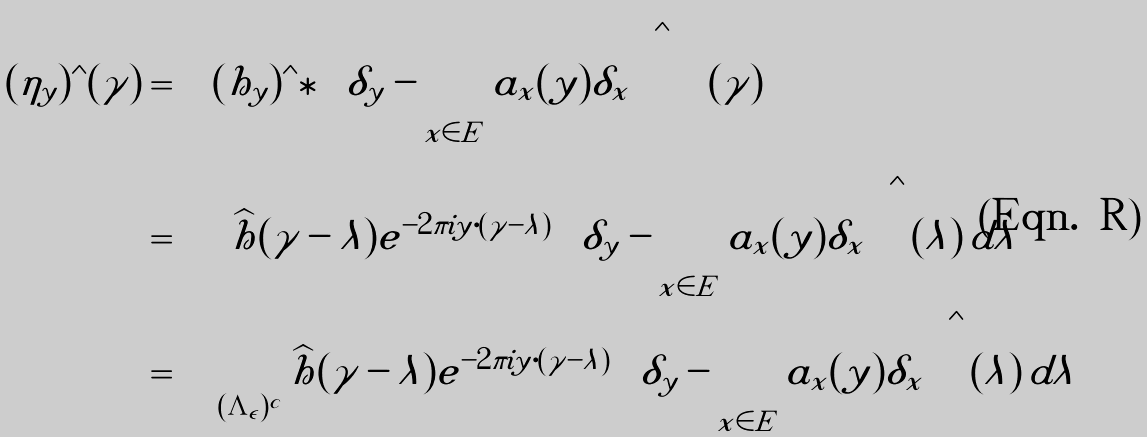Convert formula to latex. <formula><loc_0><loc_0><loc_500><loc_500>( \eta _ { y } ) ^ { \wedge } ( \gamma ) & = \left [ ( h _ { y } ) ^ { \wedge } \ast \left ( \delta _ { y } - \sum _ { x \in E } a _ { x } ( y ) \delta _ { x } \right ) ^ { \wedge } \right ] ( \gamma ) \\ & = \int \widehat { h } ( \gamma - \lambda ) e ^ { - 2 \pi i y \cdot ( \gamma - \lambda ) } \left ( \delta _ { y } - \sum _ { x \in E } a _ { x } ( y ) \delta _ { x } \right ) ^ { \wedge } ( \lambda ) \, d \lambda \\ & = \int _ { ( \Lambda _ { \epsilon } ) ^ { c } } \widehat { h } ( \gamma - \lambda ) e ^ { - 2 \pi i y \cdot ( \gamma - \lambda ) } \left ( \delta _ { y } - \sum _ { x \in E } a _ { x } ( y ) \delta _ { x } \right ) ^ { \wedge } ( \lambda ) \, d \lambda \\</formula> 